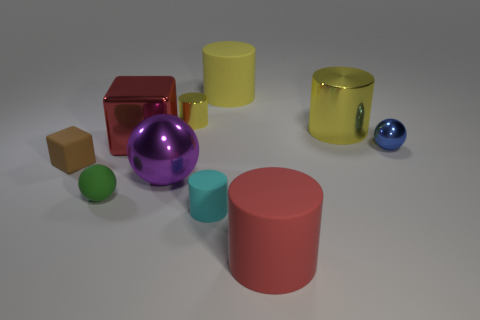Subtract all gray blocks. How many yellow cylinders are left? 3 Subtract 1 cylinders. How many cylinders are left? 4 Subtract all red cylinders. How many cylinders are left? 4 Subtract all cyan cylinders. How many cylinders are left? 4 Subtract all green cylinders. Subtract all red blocks. How many cylinders are left? 5 Subtract all blocks. How many objects are left? 8 Add 5 large red objects. How many large red objects are left? 7 Add 9 brown matte things. How many brown matte things exist? 10 Subtract 0 cyan cubes. How many objects are left? 10 Subtract all big gray matte cubes. Subtract all yellow shiny cylinders. How many objects are left? 8 